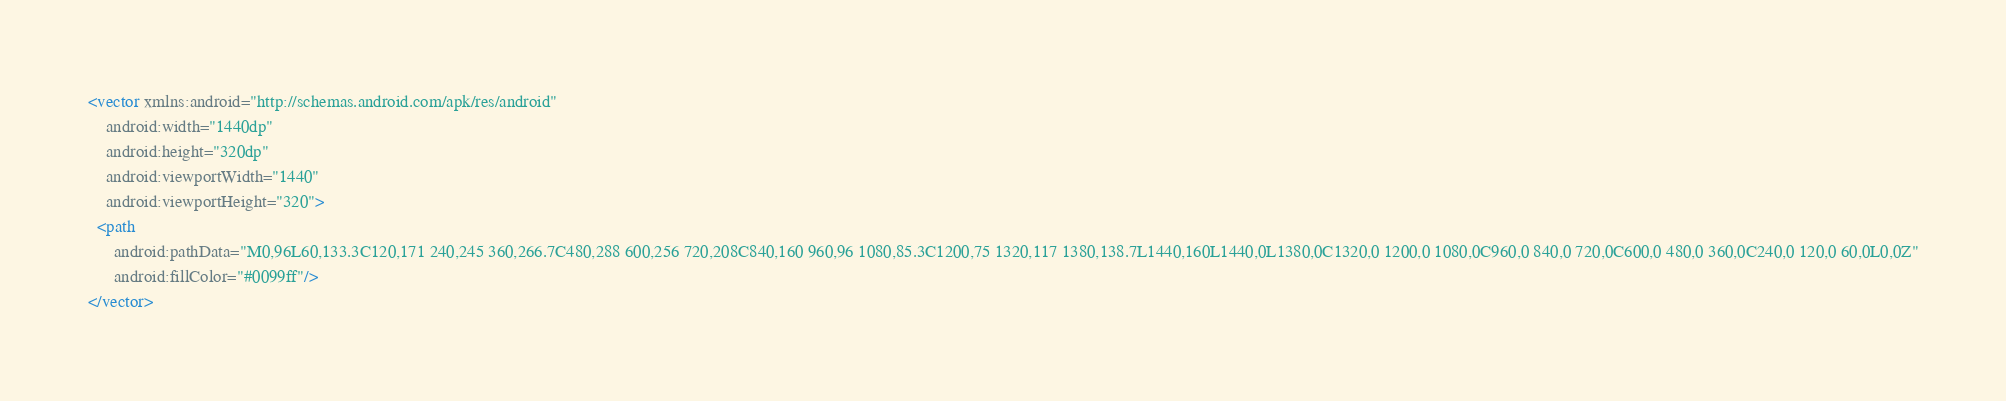Convert code to text. <code><loc_0><loc_0><loc_500><loc_500><_XML_><vector xmlns:android="http://schemas.android.com/apk/res/android"
    android:width="1440dp"
    android:height="320dp"
    android:viewportWidth="1440"
    android:viewportHeight="320">
  <path
      android:pathData="M0,96L60,133.3C120,171 240,245 360,266.7C480,288 600,256 720,208C840,160 960,96 1080,85.3C1200,75 1320,117 1380,138.7L1440,160L1440,0L1380,0C1320,0 1200,0 1080,0C960,0 840,0 720,0C600,0 480,0 360,0C240,0 120,0 60,0L0,0Z"
      android:fillColor="#0099ff"/>
</vector>
</code> 